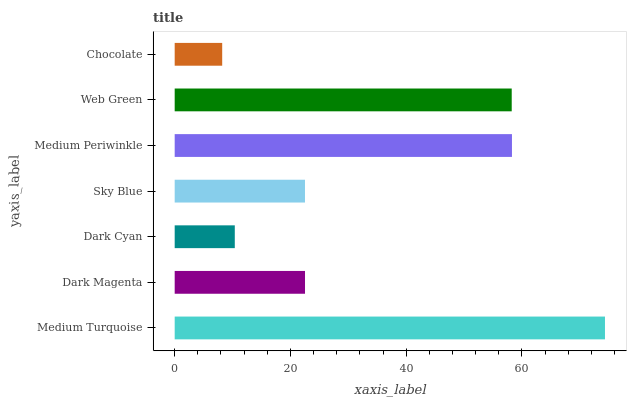Is Chocolate the minimum?
Answer yes or no. Yes. Is Medium Turquoise the maximum?
Answer yes or no. Yes. Is Dark Magenta the minimum?
Answer yes or no. No. Is Dark Magenta the maximum?
Answer yes or no. No. Is Medium Turquoise greater than Dark Magenta?
Answer yes or no. Yes. Is Dark Magenta less than Medium Turquoise?
Answer yes or no. Yes. Is Dark Magenta greater than Medium Turquoise?
Answer yes or no. No. Is Medium Turquoise less than Dark Magenta?
Answer yes or no. No. Is Dark Magenta the high median?
Answer yes or no. Yes. Is Dark Magenta the low median?
Answer yes or no. Yes. Is Medium Turquoise the high median?
Answer yes or no. No. Is Sky Blue the low median?
Answer yes or no. No. 